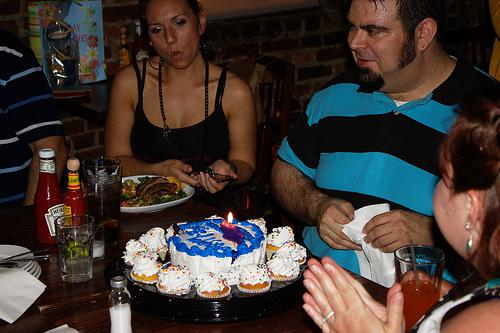Question: where is the man's napkin?
Choices:
A. On the table.
B. On the counter.
C. In his lap.
D. In his hands.
Answer with the letter. Answer: D Question: what is The man holding?
Choices:
A. Napkin.
B. Fork.
C. Knife.
D. Spoon.
Answer with the letter. Answer: A Question: when will the candle be blown out?
Choices:
A. In an hour.
B. Right now.
C. At night.
D. At dawn.
Answer with the letter. Answer: B Question: who made the cake?
Choices:
A. Baker.
B. The man.
C. The woman.
D. The chef.
Answer with the letter. Answer: A Question: what color is the man's hair?
Choices:
A. Blue.
B. Green.
C. Black.
D. Yellow.
Answer with the letter. Answer: C 